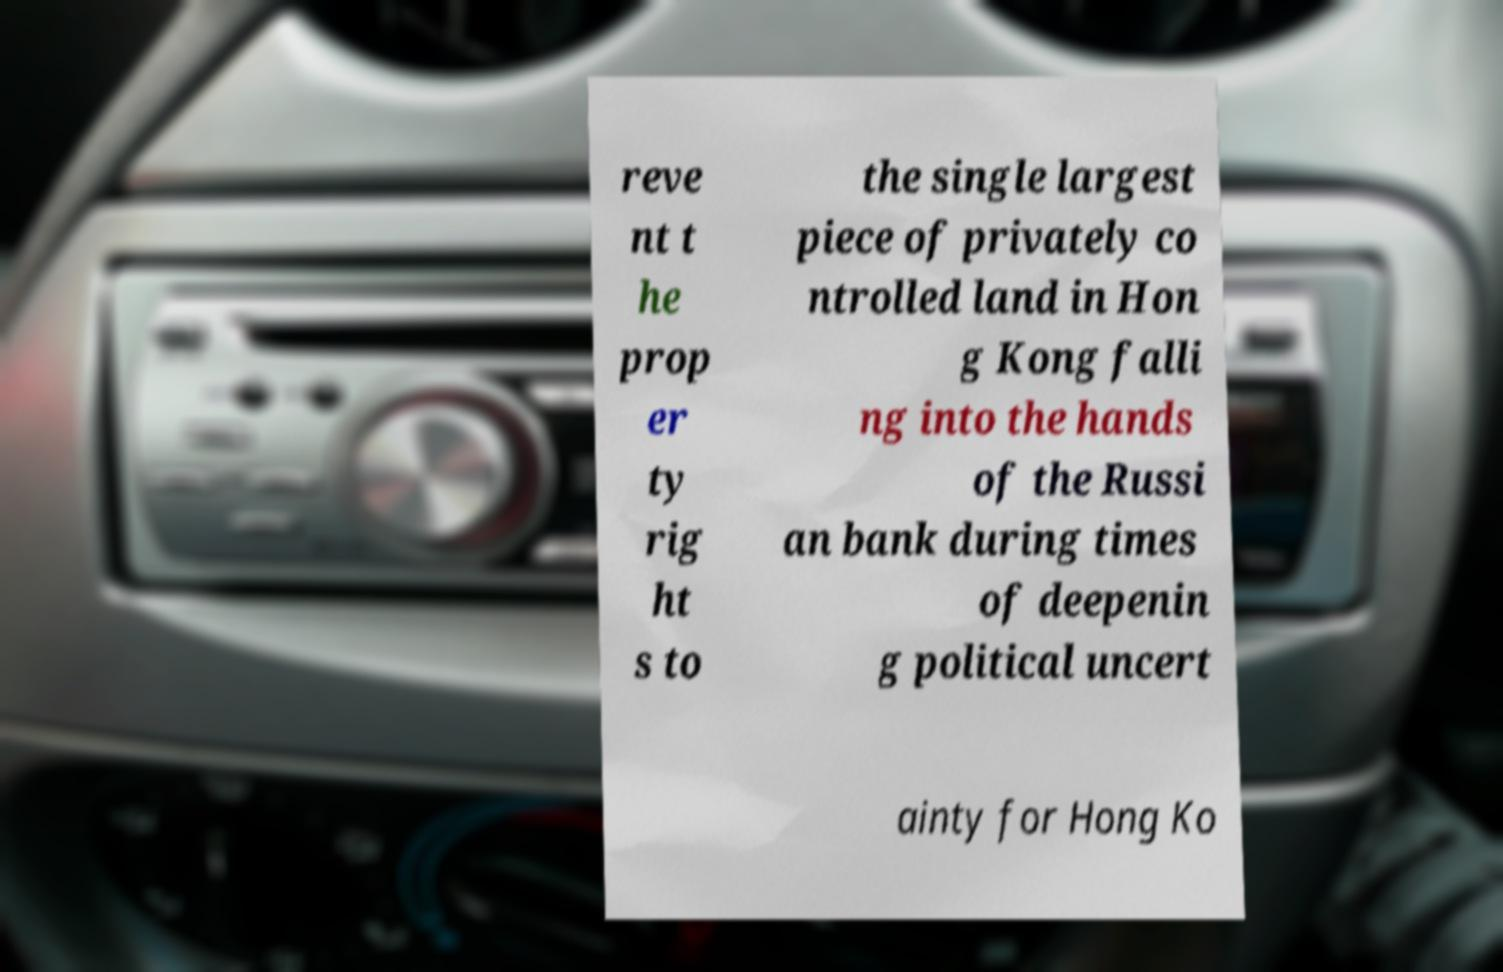Please read and relay the text visible in this image. What does it say? reve nt t he prop er ty rig ht s to the single largest piece of privately co ntrolled land in Hon g Kong falli ng into the hands of the Russi an bank during times of deepenin g political uncert ainty for Hong Ko 